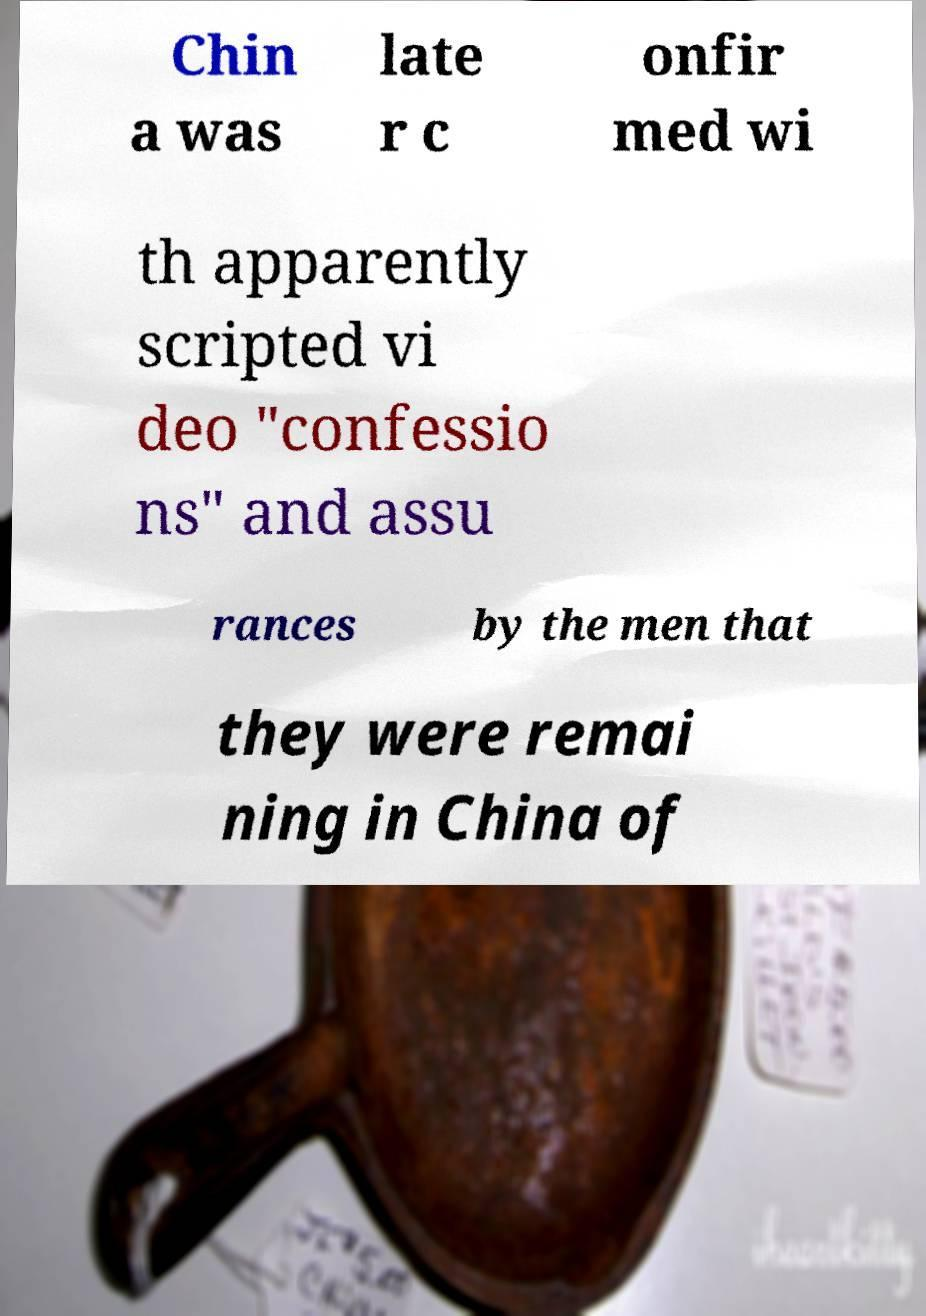Can you accurately transcribe the text from the provided image for me? Chin a was late r c onfir med wi th apparently scripted vi deo "confessio ns" and assu rances by the men that they were remai ning in China of 